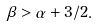Convert formula to latex. <formula><loc_0><loc_0><loc_500><loc_500>\beta > \alpha + 3 / 2 .</formula> 